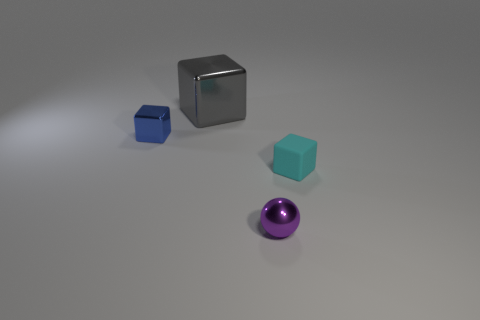What number of cyan metal cylinders have the same size as the sphere? 0 